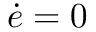Convert formula to latex. <formula><loc_0><loc_0><loc_500><loc_500>{ \dot { e } } = 0</formula> 